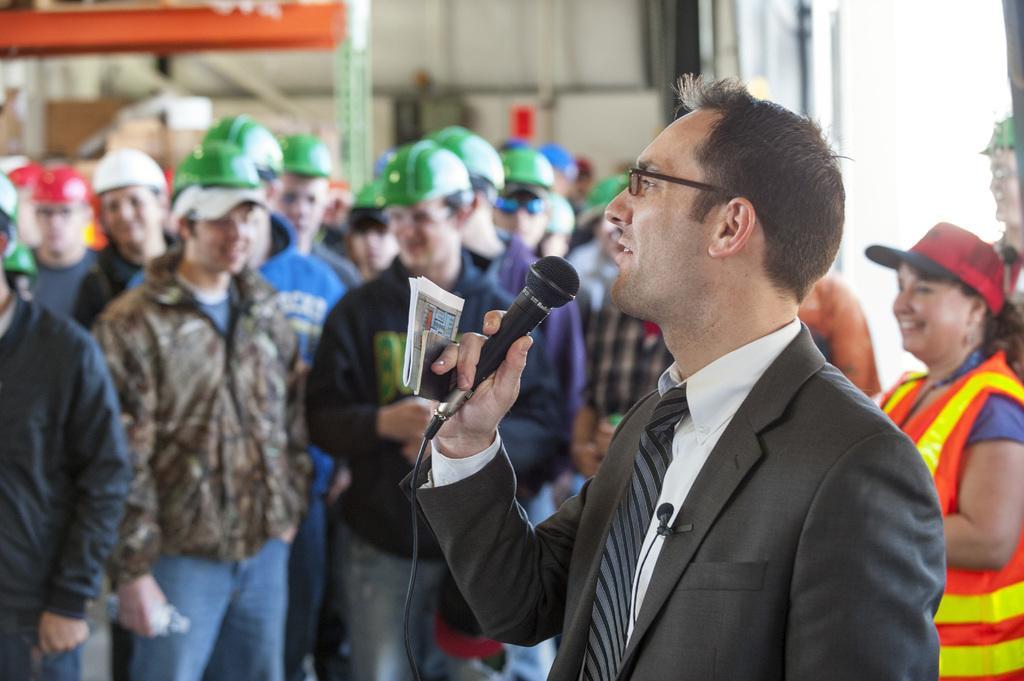Please provide a concise description of this image. In this image, there are group of people standing and wearing green color helmets on their head and also white and red caps. In the middle of the image right, there is one person standing, who's wearing a black color suit and holding a mike in his hand. In the right bottom of the image, there is one woman standing, who's having smile on her face and having a red and blue color cap on her head. In the background, there is a orange color and white color wall visible. The picture looks as if it is taken inside the factory. 